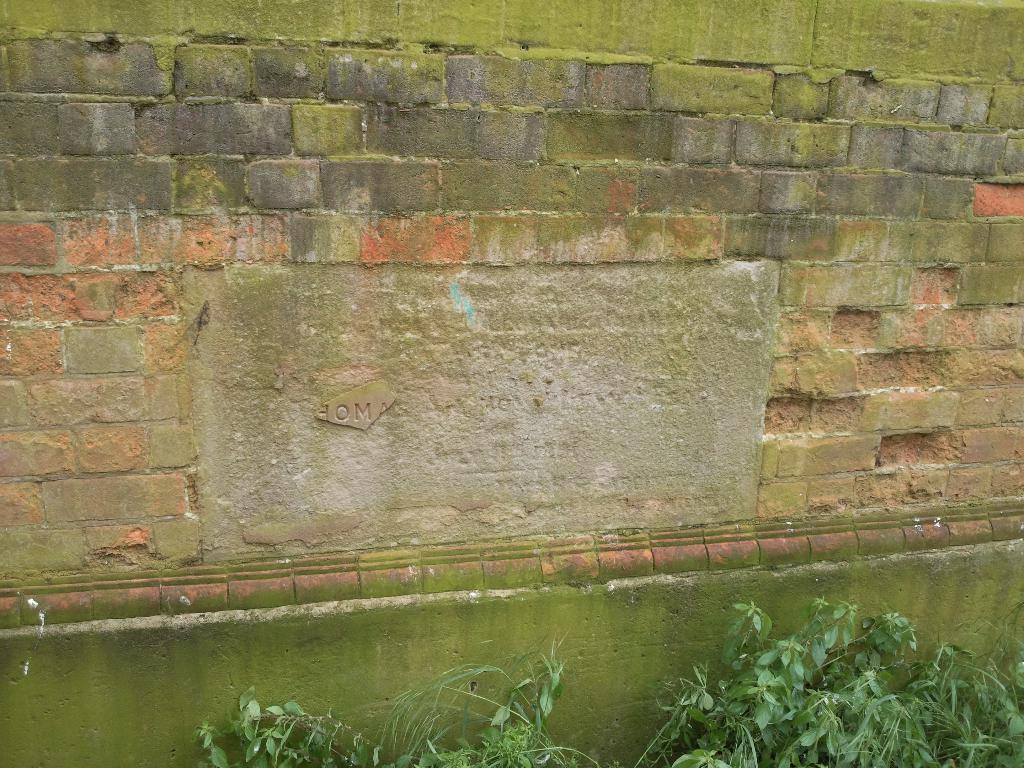What type of structure is visible in the image? There is a brick wall in the image. What can be seen at the bottom of the image? There are plants at the bottom of the image. What emotion does the brick wall express in the image? The brick wall does not express any emotions, as it is an inanimate object. 